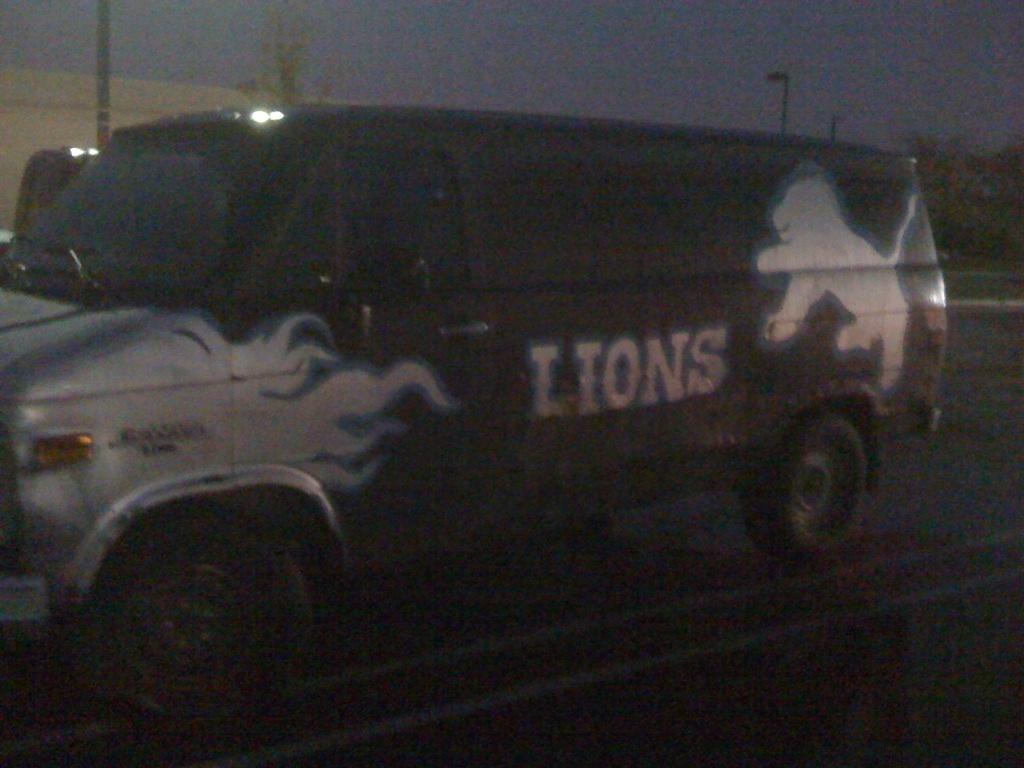What is the lighting condition in the image? The image was taken in the dark. What can be seen on the road in the image? There is a vehicle on the road in the image. What structures are visible in the background of the image? There are light poles in the background of the image. What is visible at the top of the image? The sky is visible at the top of the image. What type of punishment is being discussed by the committee in the image? There is no committee or discussion of punishment present in the image. 